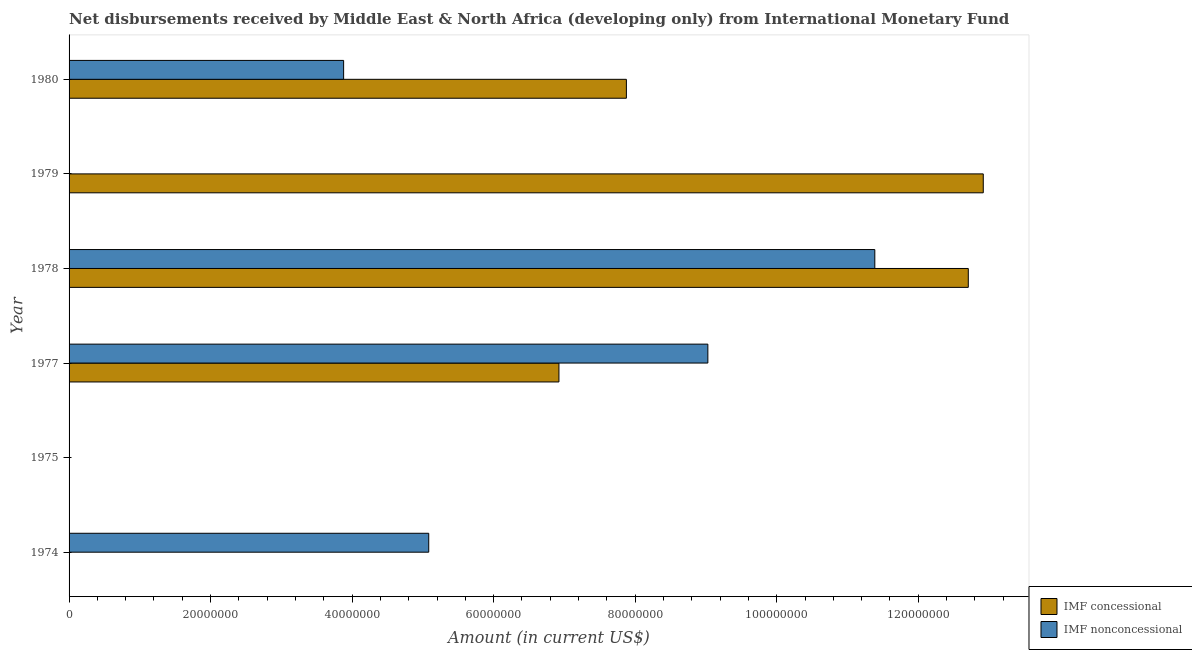How many different coloured bars are there?
Your answer should be compact. 2. Are the number of bars on each tick of the Y-axis equal?
Provide a succinct answer. No. How many bars are there on the 1st tick from the bottom?
Offer a terse response. 1. What is the label of the 4th group of bars from the top?
Keep it short and to the point. 1977. In how many cases, is the number of bars for a given year not equal to the number of legend labels?
Your response must be concise. 3. What is the net non concessional disbursements from imf in 1977?
Keep it short and to the point. 9.03e+07. Across all years, what is the maximum net concessional disbursements from imf?
Ensure brevity in your answer.  1.29e+08. Across all years, what is the minimum net concessional disbursements from imf?
Your answer should be very brief. 0. In which year was the net concessional disbursements from imf maximum?
Make the answer very short. 1979. What is the total net non concessional disbursements from imf in the graph?
Your answer should be compact. 2.94e+08. What is the difference between the net concessional disbursements from imf in 1977 and that in 1978?
Offer a very short reply. -5.78e+07. What is the difference between the net concessional disbursements from imf in 1975 and the net non concessional disbursements from imf in 1977?
Offer a terse response. -9.03e+07. What is the average net concessional disbursements from imf per year?
Give a very brief answer. 6.74e+07. In the year 1977, what is the difference between the net concessional disbursements from imf and net non concessional disbursements from imf?
Your answer should be very brief. -2.10e+07. What is the ratio of the net concessional disbursements from imf in 1977 to that in 1978?
Your answer should be very brief. 0.55. What is the difference between the highest and the second highest net non concessional disbursements from imf?
Your answer should be very brief. 2.36e+07. What is the difference between the highest and the lowest net non concessional disbursements from imf?
Ensure brevity in your answer.  1.14e+08. In how many years, is the net concessional disbursements from imf greater than the average net concessional disbursements from imf taken over all years?
Offer a very short reply. 4. How many bars are there?
Provide a succinct answer. 8. How many years are there in the graph?
Your response must be concise. 6. Does the graph contain grids?
Your response must be concise. No. How many legend labels are there?
Give a very brief answer. 2. What is the title of the graph?
Provide a succinct answer. Net disbursements received by Middle East & North Africa (developing only) from International Monetary Fund. Does "From Government" appear as one of the legend labels in the graph?
Provide a succinct answer. No. What is the label or title of the Y-axis?
Ensure brevity in your answer.  Year. What is the Amount (in current US$) of IMF concessional in 1974?
Your response must be concise. 0. What is the Amount (in current US$) in IMF nonconcessional in 1974?
Provide a short and direct response. 5.08e+07. What is the Amount (in current US$) in IMF concessional in 1977?
Provide a short and direct response. 6.92e+07. What is the Amount (in current US$) of IMF nonconcessional in 1977?
Your answer should be very brief. 9.03e+07. What is the Amount (in current US$) in IMF concessional in 1978?
Your response must be concise. 1.27e+08. What is the Amount (in current US$) in IMF nonconcessional in 1978?
Keep it short and to the point. 1.14e+08. What is the Amount (in current US$) of IMF concessional in 1979?
Offer a terse response. 1.29e+08. What is the Amount (in current US$) of IMF concessional in 1980?
Offer a very short reply. 7.88e+07. What is the Amount (in current US$) of IMF nonconcessional in 1980?
Provide a succinct answer. 3.88e+07. Across all years, what is the maximum Amount (in current US$) of IMF concessional?
Your answer should be compact. 1.29e+08. Across all years, what is the maximum Amount (in current US$) of IMF nonconcessional?
Make the answer very short. 1.14e+08. Across all years, what is the minimum Amount (in current US$) in IMF nonconcessional?
Offer a very short reply. 0. What is the total Amount (in current US$) of IMF concessional in the graph?
Offer a very short reply. 4.04e+08. What is the total Amount (in current US$) of IMF nonconcessional in the graph?
Provide a succinct answer. 2.94e+08. What is the difference between the Amount (in current US$) in IMF nonconcessional in 1974 and that in 1977?
Keep it short and to the point. -3.94e+07. What is the difference between the Amount (in current US$) in IMF nonconcessional in 1974 and that in 1978?
Your response must be concise. -6.30e+07. What is the difference between the Amount (in current US$) of IMF nonconcessional in 1974 and that in 1980?
Give a very brief answer. 1.20e+07. What is the difference between the Amount (in current US$) of IMF concessional in 1977 and that in 1978?
Provide a succinct answer. -5.78e+07. What is the difference between the Amount (in current US$) in IMF nonconcessional in 1977 and that in 1978?
Keep it short and to the point. -2.36e+07. What is the difference between the Amount (in current US$) in IMF concessional in 1977 and that in 1979?
Offer a terse response. -6.00e+07. What is the difference between the Amount (in current US$) in IMF concessional in 1977 and that in 1980?
Your answer should be very brief. -9.53e+06. What is the difference between the Amount (in current US$) of IMF nonconcessional in 1977 and that in 1980?
Your response must be concise. 5.15e+07. What is the difference between the Amount (in current US$) in IMF concessional in 1978 and that in 1979?
Offer a terse response. -2.12e+06. What is the difference between the Amount (in current US$) in IMF concessional in 1978 and that in 1980?
Ensure brevity in your answer.  4.83e+07. What is the difference between the Amount (in current US$) of IMF nonconcessional in 1978 and that in 1980?
Keep it short and to the point. 7.51e+07. What is the difference between the Amount (in current US$) of IMF concessional in 1979 and that in 1980?
Make the answer very short. 5.04e+07. What is the difference between the Amount (in current US$) of IMF concessional in 1977 and the Amount (in current US$) of IMF nonconcessional in 1978?
Provide a succinct answer. -4.46e+07. What is the difference between the Amount (in current US$) in IMF concessional in 1977 and the Amount (in current US$) in IMF nonconcessional in 1980?
Provide a short and direct response. 3.04e+07. What is the difference between the Amount (in current US$) of IMF concessional in 1978 and the Amount (in current US$) of IMF nonconcessional in 1980?
Offer a terse response. 8.83e+07. What is the difference between the Amount (in current US$) in IMF concessional in 1979 and the Amount (in current US$) in IMF nonconcessional in 1980?
Keep it short and to the point. 9.04e+07. What is the average Amount (in current US$) in IMF concessional per year?
Your response must be concise. 6.74e+07. What is the average Amount (in current US$) in IMF nonconcessional per year?
Ensure brevity in your answer.  4.90e+07. In the year 1977, what is the difference between the Amount (in current US$) of IMF concessional and Amount (in current US$) of IMF nonconcessional?
Your answer should be very brief. -2.10e+07. In the year 1978, what is the difference between the Amount (in current US$) of IMF concessional and Amount (in current US$) of IMF nonconcessional?
Give a very brief answer. 1.32e+07. In the year 1980, what is the difference between the Amount (in current US$) in IMF concessional and Amount (in current US$) in IMF nonconcessional?
Your response must be concise. 4.00e+07. What is the ratio of the Amount (in current US$) of IMF nonconcessional in 1974 to that in 1977?
Your answer should be very brief. 0.56. What is the ratio of the Amount (in current US$) of IMF nonconcessional in 1974 to that in 1978?
Offer a very short reply. 0.45. What is the ratio of the Amount (in current US$) of IMF nonconcessional in 1974 to that in 1980?
Offer a very short reply. 1.31. What is the ratio of the Amount (in current US$) in IMF concessional in 1977 to that in 1978?
Your response must be concise. 0.54. What is the ratio of the Amount (in current US$) of IMF nonconcessional in 1977 to that in 1978?
Ensure brevity in your answer.  0.79. What is the ratio of the Amount (in current US$) in IMF concessional in 1977 to that in 1979?
Keep it short and to the point. 0.54. What is the ratio of the Amount (in current US$) of IMF concessional in 1977 to that in 1980?
Offer a very short reply. 0.88. What is the ratio of the Amount (in current US$) of IMF nonconcessional in 1977 to that in 1980?
Offer a terse response. 2.33. What is the ratio of the Amount (in current US$) of IMF concessional in 1978 to that in 1979?
Ensure brevity in your answer.  0.98. What is the ratio of the Amount (in current US$) of IMF concessional in 1978 to that in 1980?
Your answer should be very brief. 1.61. What is the ratio of the Amount (in current US$) of IMF nonconcessional in 1978 to that in 1980?
Provide a short and direct response. 2.93. What is the ratio of the Amount (in current US$) in IMF concessional in 1979 to that in 1980?
Provide a short and direct response. 1.64. What is the difference between the highest and the second highest Amount (in current US$) in IMF concessional?
Your answer should be compact. 2.12e+06. What is the difference between the highest and the second highest Amount (in current US$) in IMF nonconcessional?
Your answer should be very brief. 2.36e+07. What is the difference between the highest and the lowest Amount (in current US$) of IMF concessional?
Offer a terse response. 1.29e+08. What is the difference between the highest and the lowest Amount (in current US$) of IMF nonconcessional?
Your response must be concise. 1.14e+08. 